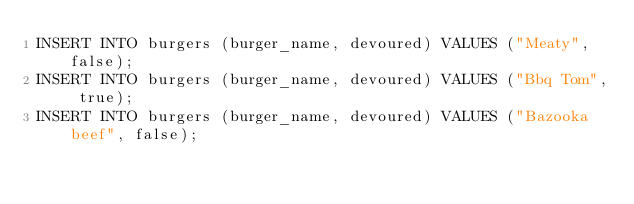<code> <loc_0><loc_0><loc_500><loc_500><_SQL_>INSERT INTO burgers (burger_name, devoured) VALUES ("Meaty", false);
INSERT INTO burgers (burger_name, devoured) VALUES ("Bbq Tom", true);
INSERT INTO burgers (burger_name, devoured) VALUES ("Bazooka beef", false);
</code> 